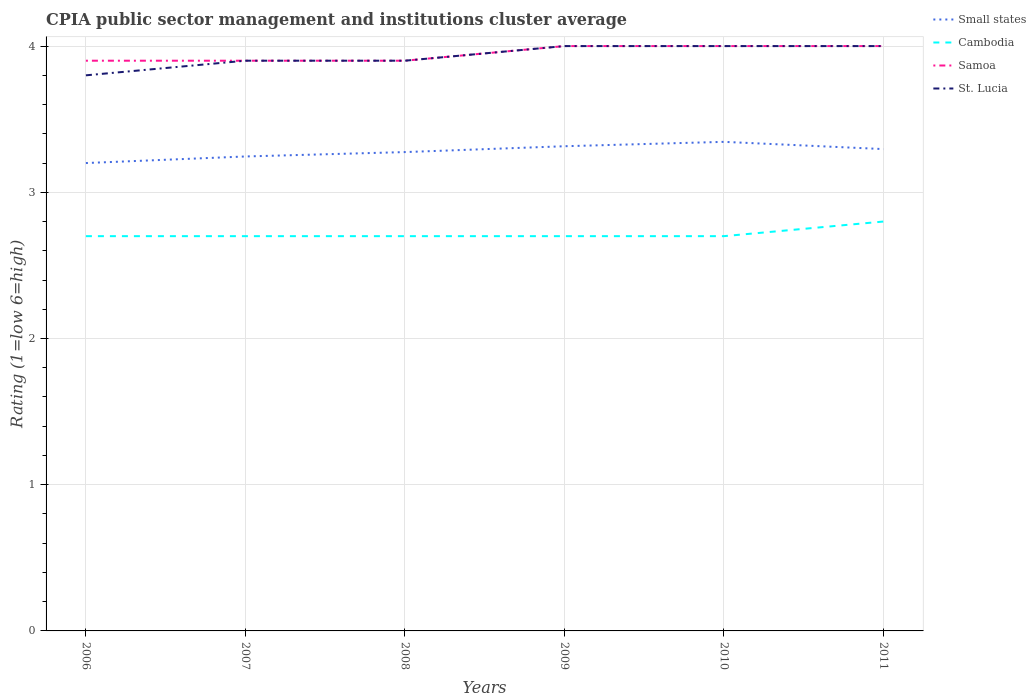How many different coloured lines are there?
Keep it short and to the point. 4. Does the line corresponding to Samoa intersect with the line corresponding to Cambodia?
Provide a succinct answer. No. Is the number of lines equal to the number of legend labels?
Provide a succinct answer. Yes. In which year was the CPIA rating in Cambodia maximum?
Your response must be concise. 2006. What is the total CPIA rating in Cambodia in the graph?
Offer a very short reply. -0.1. What is the difference between the highest and the second highest CPIA rating in Cambodia?
Keep it short and to the point. 0.1. Is the CPIA rating in St. Lucia strictly greater than the CPIA rating in Small states over the years?
Ensure brevity in your answer.  No. How many lines are there?
Provide a succinct answer. 4. How many years are there in the graph?
Make the answer very short. 6. What is the difference between two consecutive major ticks on the Y-axis?
Give a very brief answer. 1. Does the graph contain any zero values?
Your answer should be very brief. No. Does the graph contain grids?
Give a very brief answer. Yes. How are the legend labels stacked?
Offer a terse response. Vertical. What is the title of the graph?
Make the answer very short. CPIA public sector management and institutions cluster average. What is the label or title of the Y-axis?
Your answer should be very brief. Rating (1=low 6=high). What is the Rating (1=low 6=high) of Small states in 2006?
Give a very brief answer. 3.2. What is the Rating (1=low 6=high) in Cambodia in 2006?
Make the answer very short. 2.7. What is the Rating (1=low 6=high) in Samoa in 2006?
Your answer should be very brief. 3.9. What is the Rating (1=low 6=high) of St. Lucia in 2006?
Your answer should be compact. 3.8. What is the Rating (1=low 6=high) of Small states in 2007?
Your response must be concise. 3.25. What is the Rating (1=low 6=high) in Cambodia in 2007?
Your answer should be compact. 2.7. What is the Rating (1=low 6=high) in Samoa in 2007?
Give a very brief answer. 3.9. What is the Rating (1=low 6=high) in Small states in 2008?
Make the answer very short. 3.27. What is the Rating (1=low 6=high) in Cambodia in 2008?
Keep it short and to the point. 2.7. What is the Rating (1=low 6=high) in Samoa in 2008?
Your answer should be compact. 3.9. What is the Rating (1=low 6=high) in Small states in 2009?
Offer a very short reply. 3.31. What is the Rating (1=low 6=high) of St. Lucia in 2009?
Keep it short and to the point. 4. What is the Rating (1=low 6=high) of Small states in 2010?
Give a very brief answer. 3.35. What is the Rating (1=low 6=high) in Samoa in 2010?
Your answer should be very brief. 4. What is the Rating (1=low 6=high) in St. Lucia in 2010?
Give a very brief answer. 4. What is the Rating (1=low 6=high) of Small states in 2011?
Offer a terse response. 3.3. What is the Rating (1=low 6=high) of Cambodia in 2011?
Your answer should be very brief. 2.8. Across all years, what is the maximum Rating (1=low 6=high) of Small states?
Your answer should be very brief. 3.35. Across all years, what is the maximum Rating (1=low 6=high) in Cambodia?
Your answer should be very brief. 2.8. Across all years, what is the maximum Rating (1=low 6=high) in St. Lucia?
Your answer should be compact. 4. Across all years, what is the minimum Rating (1=low 6=high) of Small states?
Your response must be concise. 3.2. What is the total Rating (1=low 6=high) of Small states in the graph?
Your answer should be very brief. 19.68. What is the total Rating (1=low 6=high) of Cambodia in the graph?
Provide a short and direct response. 16.3. What is the total Rating (1=low 6=high) in Samoa in the graph?
Offer a terse response. 23.7. What is the total Rating (1=low 6=high) in St. Lucia in the graph?
Provide a succinct answer. 23.6. What is the difference between the Rating (1=low 6=high) of Small states in 2006 and that in 2007?
Offer a very short reply. -0.04. What is the difference between the Rating (1=low 6=high) of Cambodia in 2006 and that in 2007?
Give a very brief answer. 0. What is the difference between the Rating (1=low 6=high) in Samoa in 2006 and that in 2007?
Your answer should be very brief. 0. What is the difference between the Rating (1=low 6=high) in St. Lucia in 2006 and that in 2007?
Give a very brief answer. -0.1. What is the difference between the Rating (1=low 6=high) in Small states in 2006 and that in 2008?
Offer a terse response. -0.07. What is the difference between the Rating (1=low 6=high) in Cambodia in 2006 and that in 2008?
Your response must be concise. 0. What is the difference between the Rating (1=low 6=high) of St. Lucia in 2006 and that in 2008?
Provide a short and direct response. -0.1. What is the difference between the Rating (1=low 6=high) in Small states in 2006 and that in 2009?
Make the answer very short. -0.12. What is the difference between the Rating (1=low 6=high) of Cambodia in 2006 and that in 2009?
Your response must be concise. 0. What is the difference between the Rating (1=low 6=high) in Samoa in 2006 and that in 2009?
Offer a very short reply. -0.1. What is the difference between the Rating (1=low 6=high) in St. Lucia in 2006 and that in 2009?
Offer a very short reply. -0.2. What is the difference between the Rating (1=low 6=high) in Small states in 2006 and that in 2010?
Your response must be concise. -0.14. What is the difference between the Rating (1=low 6=high) in Cambodia in 2006 and that in 2010?
Your answer should be compact. 0. What is the difference between the Rating (1=low 6=high) of Small states in 2006 and that in 2011?
Give a very brief answer. -0.1. What is the difference between the Rating (1=low 6=high) in Cambodia in 2006 and that in 2011?
Give a very brief answer. -0.1. What is the difference between the Rating (1=low 6=high) in Samoa in 2006 and that in 2011?
Make the answer very short. -0.1. What is the difference between the Rating (1=low 6=high) of Small states in 2007 and that in 2008?
Your response must be concise. -0.03. What is the difference between the Rating (1=low 6=high) of Cambodia in 2007 and that in 2008?
Keep it short and to the point. 0. What is the difference between the Rating (1=low 6=high) in Samoa in 2007 and that in 2008?
Offer a very short reply. 0. What is the difference between the Rating (1=low 6=high) of St. Lucia in 2007 and that in 2008?
Provide a succinct answer. 0. What is the difference between the Rating (1=low 6=high) of Small states in 2007 and that in 2009?
Make the answer very short. -0.07. What is the difference between the Rating (1=low 6=high) of Cambodia in 2007 and that in 2009?
Offer a very short reply. 0. What is the difference between the Rating (1=low 6=high) of Samoa in 2007 and that in 2009?
Keep it short and to the point. -0.1. What is the difference between the Rating (1=low 6=high) in Small states in 2007 and that in 2010?
Provide a succinct answer. -0.1. What is the difference between the Rating (1=low 6=high) in St. Lucia in 2007 and that in 2010?
Provide a succinct answer. -0.1. What is the difference between the Rating (1=low 6=high) of Small states in 2007 and that in 2011?
Your response must be concise. -0.05. What is the difference between the Rating (1=low 6=high) of Samoa in 2007 and that in 2011?
Give a very brief answer. -0.1. What is the difference between the Rating (1=low 6=high) in Small states in 2008 and that in 2009?
Your answer should be very brief. -0.04. What is the difference between the Rating (1=low 6=high) in St. Lucia in 2008 and that in 2009?
Make the answer very short. -0.1. What is the difference between the Rating (1=low 6=high) in Small states in 2008 and that in 2010?
Keep it short and to the point. -0.07. What is the difference between the Rating (1=low 6=high) in Cambodia in 2008 and that in 2010?
Offer a terse response. 0. What is the difference between the Rating (1=low 6=high) in Samoa in 2008 and that in 2010?
Your answer should be very brief. -0.1. What is the difference between the Rating (1=low 6=high) in Small states in 2008 and that in 2011?
Provide a succinct answer. -0.02. What is the difference between the Rating (1=low 6=high) in Small states in 2009 and that in 2010?
Give a very brief answer. -0.03. What is the difference between the Rating (1=low 6=high) of Cambodia in 2009 and that in 2010?
Your answer should be very brief. 0. What is the difference between the Rating (1=low 6=high) in St. Lucia in 2009 and that in 2010?
Offer a very short reply. 0. What is the difference between the Rating (1=low 6=high) of Small states in 2009 and that in 2011?
Your response must be concise. 0.02. What is the difference between the Rating (1=low 6=high) in St. Lucia in 2009 and that in 2011?
Your answer should be very brief. 0. What is the difference between the Rating (1=low 6=high) of Small states in 2010 and that in 2011?
Make the answer very short. 0.05. What is the difference between the Rating (1=low 6=high) of Cambodia in 2010 and that in 2011?
Your answer should be very brief. -0.1. What is the difference between the Rating (1=low 6=high) of Samoa in 2010 and that in 2011?
Your answer should be compact. 0. What is the difference between the Rating (1=low 6=high) of Small states in 2006 and the Rating (1=low 6=high) of St. Lucia in 2007?
Offer a very short reply. -0.7. What is the difference between the Rating (1=low 6=high) in Cambodia in 2006 and the Rating (1=low 6=high) in St. Lucia in 2007?
Make the answer very short. -1.2. What is the difference between the Rating (1=low 6=high) of Samoa in 2006 and the Rating (1=low 6=high) of St. Lucia in 2007?
Your answer should be compact. 0. What is the difference between the Rating (1=low 6=high) in Small states in 2006 and the Rating (1=low 6=high) in Cambodia in 2008?
Offer a very short reply. 0.5. What is the difference between the Rating (1=low 6=high) of Cambodia in 2006 and the Rating (1=low 6=high) of St. Lucia in 2008?
Offer a terse response. -1.2. What is the difference between the Rating (1=low 6=high) of Small states in 2006 and the Rating (1=low 6=high) of Samoa in 2009?
Offer a very short reply. -0.8. What is the difference between the Rating (1=low 6=high) in Small states in 2006 and the Rating (1=low 6=high) in St. Lucia in 2009?
Your answer should be very brief. -0.8. What is the difference between the Rating (1=low 6=high) of Cambodia in 2006 and the Rating (1=low 6=high) of Samoa in 2009?
Your answer should be very brief. -1.3. What is the difference between the Rating (1=low 6=high) in Small states in 2006 and the Rating (1=low 6=high) in Samoa in 2010?
Your answer should be very brief. -0.8. What is the difference between the Rating (1=low 6=high) of Cambodia in 2006 and the Rating (1=low 6=high) of Samoa in 2010?
Make the answer very short. -1.3. What is the difference between the Rating (1=low 6=high) in Small states in 2006 and the Rating (1=low 6=high) in Samoa in 2011?
Offer a very short reply. -0.8. What is the difference between the Rating (1=low 6=high) of Small states in 2006 and the Rating (1=low 6=high) of St. Lucia in 2011?
Ensure brevity in your answer.  -0.8. What is the difference between the Rating (1=low 6=high) of Samoa in 2006 and the Rating (1=low 6=high) of St. Lucia in 2011?
Give a very brief answer. -0.1. What is the difference between the Rating (1=low 6=high) of Small states in 2007 and the Rating (1=low 6=high) of Cambodia in 2008?
Make the answer very short. 0.55. What is the difference between the Rating (1=low 6=high) in Small states in 2007 and the Rating (1=low 6=high) in Samoa in 2008?
Ensure brevity in your answer.  -0.66. What is the difference between the Rating (1=low 6=high) of Small states in 2007 and the Rating (1=low 6=high) of St. Lucia in 2008?
Your response must be concise. -0.66. What is the difference between the Rating (1=low 6=high) of Cambodia in 2007 and the Rating (1=low 6=high) of Samoa in 2008?
Ensure brevity in your answer.  -1.2. What is the difference between the Rating (1=low 6=high) of Small states in 2007 and the Rating (1=low 6=high) of Cambodia in 2009?
Offer a terse response. 0.55. What is the difference between the Rating (1=low 6=high) in Small states in 2007 and the Rating (1=low 6=high) in Samoa in 2009?
Make the answer very short. -0.76. What is the difference between the Rating (1=low 6=high) in Small states in 2007 and the Rating (1=low 6=high) in St. Lucia in 2009?
Keep it short and to the point. -0.76. What is the difference between the Rating (1=low 6=high) of Cambodia in 2007 and the Rating (1=low 6=high) of St. Lucia in 2009?
Your response must be concise. -1.3. What is the difference between the Rating (1=low 6=high) in Small states in 2007 and the Rating (1=low 6=high) in Cambodia in 2010?
Your answer should be compact. 0.55. What is the difference between the Rating (1=low 6=high) of Small states in 2007 and the Rating (1=low 6=high) of Samoa in 2010?
Your answer should be compact. -0.76. What is the difference between the Rating (1=low 6=high) of Small states in 2007 and the Rating (1=low 6=high) of St. Lucia in 2010?
Your answer should be very brief. -0.76. What is the difference between the Rating (1=low 6=high) in Samoa in 2007 and the Rating (1=low 6=high) in St. Lucia in 2010?
Make the answer very short. -0.1. What is the difference between the Rating (1=low 6=high) of Small states in 2007 and the Rating (1=low 6=high) of Cambodia in 2011?
Your answer should be very brief. 0.45. What is the difference between the Rating (1=low 6=high) of Small states in 2007 and the Rating (1=low 6=high) of Samoa in 2011?
Give a very brief answer. -0.76. What is the difference between the Rating (1=low 6=high) in Small states in 2007 and the Rating (1=low 6=high) in St. Lucia in 2011?
Make the answer very short. -0.76. What is the difference between the Rating (1=low 6=high) of Small states in 2008 and the Rating (1=low 6=high) of Cambodia in 2009?
Keep it short and to the point. 0.57. What is the difference between the Rating (1=low 6=high) in Small states in 2008 and the Rating (1=low 6=high) in Samoa in 2009?
Offer a terse response. -0.72. What is the difference between the Rating (1=low 6=high) of Small states in 2008 and the Rating (1=low 6=high) of St. Lucia in 2009?
Ensure brevity in your answer.  -0.72. What is the difference between the Rating (1=low 6=high) in Cambodia in 2008 and the Rating (1=low 6=high) in Samoa in 2009?
Make the answer very short. -1.3. What is the difference between the Rating (1=low 6=high) in Small states in 2008 and the Rating (1=low 6=high) in Cambodia in 2010?
Offer a very short reply. 0.57. What is the difference between the Rating (1=low 6=high) of Small states in 2008 and the Rating (1=low 6=high) of Samoa in 2010?
Provide a succinct answer. -0.72. What is the difference between the Rating (1=low 6=high) in Small states in 2008 and the Rating (1=low 6=high) in St. Lucia in 2010?
Provide a succinct answer. -0.72. What is the difference between the Rating (1=low 6=high) in Cambodia in 2008 and the Rating (1=low 6=high) in Samoa in 2010?
Keep it short and to the point. -1.3. What is the difference between the Rating (1=low 6=high) in Cambodia in 2008 and the Rating (1=low 6=high) in St. Lucia in 2010?
Ensure brevity in your answer.  -1.3. What is the difference between the Rating (1=low 6=high) in Samoa in 2008 and the Rating (1=low 6=high) in St. Lucia in 2010?
Offer a very short reply. -0.1. What is the difference between the Rating (1=low 6=high) of Small states in 2008 and the Rating (1=low 6=high) of Cambodia in 2011?
Your answer should be compact. 0.47. What is the difference between the Rating (1=low 6=high) of Small states in 2008 and the Rating (1=low 6=high) of Samoa in 2011?
Provide a succinct answer. -0.72. What is the difference between the Rating (1=low 6=high) of Small states in 2008 and the Rating (1=low 6=high) of St. Lucia in 2011?
Keep it short and to the point. -0.72. What is the difference between the Rating (1=low 6=high) in Small states in 2009 and the Rating (1=low 6=high) in Cambodia in 2010?
Provide a succinct answer. 0.61. What is the difference between the Rating (1=low 6=high) of Small states in 2009 and the Rating (1=low 6=high) of Samoa in 2010?
Provide a short and direct response. -0.69. What is the difference between the Rating (1=low 6=high) in Small states in 2009 and the Rating (1=low 6=high) in St. Lucia in 2010?
Keep it short and to the point. -0.69. What is the difference between the Rating (1=low 6=high) in Cambodia in 2009 and the Rating (1=low 6=high) in Samoa in 2010?
Keep it short and to the point. -1.3. What is the difference between the Rating (1=low 6=high) of Cambodia in 2009 and the Rating (1=low 6=high) of St. Lucia in 2010?
Your answer should be very brief. -1.3. What is the difference between the Rating (1=low 6=high) of Small states in 2009 and the Rating (1=low 6=high) of Cambodia in 2011?
Keep it short and to the point. 0.52. What is the difference between the Rating (1=low 6=high) in Small states in 2009 and the Rating (1=low 6=high) in Samoa in 2011?
Keep it short and to the point. -0.69. What is the difference between the Rating (1=low 6=high) of Small states in 2009 and the Rating (1=low 6=high) of St. Lucia in 2011?
Offer a terse response. -0.69. What is the difference between the Rating (1=low 6=high) in Cambodia in 2009 and the Rating (1=low 6=high) in Samoa in 2011?
Ensure brevity in your answer.  -1.3. What is the difference between the Rating (1=low 6=high) in Small states in 2010 and the Rating (1=low 6=high) in Cambodia in 2011?
Ensure brevity in your answer.  0.55. What is the difference between the Rating (1=low 6=high) in Small states in 2010 and the Rating (1=low 6=high) in Samoa in 2011?
Give a very brief answer. -0.66. What is the difference between the Rating (1=low 6=high) in Small states in 2010 and the Rating (1=low 6=high) in St. Lucia in 2011?
Give a very brief answer. -0.66. What is the difference between the Rating (1=low 6=high) of Cambodia in 2010 and the Rating (1=low 6=high) of St. Lucia in 2011?
Give a very brief answer. -1.3. What is the average Rating (1=low 6=high) of Small states per year?
Provide a succinct answer. 3.28. What is the average Rating (1=low 6=high) of Cambodia per year?
Make the answer very short. 2.72. What is the average Rating (1=low 6=high) in Samoa per year?
Your answer should be very brief. 3.95. What is the average Rating (1=low 6=high) of St. Lucia per year?
Provide a short and direct response. 3.93. In the year 2006, what is the difference between the Rating (1=low 6=high) of Small states and Rating (1=low 6=high) of St. Lucia?
Offer a very short reply. -0.6. In the year 2006, what is the difference between the Rating (1=low 6=high) of Samoa and Rating (1=low 6=high) of St. Lucia?
Your answer should be compact. 0.1. In the year 2007, what is the difference between the Rating (1=low 6=high) in Small states and Rating (1=low 6=high) in Cambodia?
Make the answer very short. 0.55. In the year 2007, what is the difference between the Rating (1=low 6=high) of Small states and Rating (1=low 6=high) of Samoa?
Provide a short and direct response. -0.66. In the year 2007, what is the difference between the Rating (1=low 6=high) of Small states and Rating (1=low 6=high) of St. Lucia?
Provide a short and direct response. -0.66. In the year 2007, what is the difference between the Rating (1=low 6=high) in Cambodia and Rating (1=low 6=high) in Samoa?
Your answer should be compact. -1.2. In the year 2007, what is the difference between the Rating (1=low 6=high) in Cambodia and Rating (1=low 6=high) in St. Lucia?
Your answer should be compact. -1.2. In the year 2008, what is the difference between the Rating (1=low 6=high) in Small states and Rating (1=low 6=high) in Cambodia?
Provide a short and direct response. 0.57. In the year 2008, what is the difference between the Rating (1=low 6=high) in Small states and Rating (1=low 6=high) in Samoa?
Your response must be concise. -0.62. In the year 2008, what is the difference between the Rating (1=low 6=high) in Small states and Rating (1=low 6=high) in St. Lucia?
Offer a very short reply. -0.62. In the year 2008, what is the difference between the Rating (1=low 6=high) in Cambodia and Rating (1=low 6=high) in St. Lucia?
Offer a terse response. -1.2. In the year 2009, what is the difference between the Rating (1=low 6=high) of Small states and Rating (1=low 6=high) of Cambodia?
Make the answer very short. 0.61. In the year 2009, what is the difference between the Rating (1=low 6=high) in Small states and Rating (1=low 6=high) in Samoa?
Give a very brief answer. -0.69. In the year 2009, what is the difference between the Rating (1=low 6=high) of Small states and Rating (1=low 6=high) of St. Lucia?
Provide a succinct answer. -0.69. In the year 2009, what is the difference between the Rating (1=low 6=high) in Cambodia and Rating (1=low 6=high) in Samoa?
Provide a succinct answer. -1.3. In the year 2009, what is the difference between the Rating (1=low 6=high) in Samoa and Rating (1=low 6=high) in St. Lucia?
Provide a short and direct response. 0. In the year 2010, what is the difference between the Rating (1=low 6=high) in Small states and Rating (1=low 6=high) in Cambodia?
Provide a short and direct response. 0.65. In the year 2010, what is the difference between the Rating (1=low 6=high) of Small states and Rating (1=low 6=high) of Samoa?
Give a very brief answer. -0.66. In the year 2010, what is the difference between the Rating (1=low 6=high) of Small states and Rating (1=low 6=high) of St. Lucia?
Offer a terse response. -0.66. In the year 2010, what is the difference between the Rating (1=low 6=high) of Cambodia and Rating (1=low 6=high) of St. Lucia?
Keep it short and to the point. -1.3. In the year 2010, what is the difference between the Rating (1=low 6=high) of Samoa and Rating (1=low 6=high) of St. Lucia?
Make the answer very short. 0. In the year 2011, what is the difference between the Rating (1=low 6=high) of Small states and Rating (1=low 6=high) of Cambodia?
Ensure brevity in your answer.  0.5. In the year 2011, what is the difference between the Rating (1=low 6=high) in Small states and Rating (1=low 6=high) in Samoa?
Offer a terse response. -0.7. In the year 2011, what is the difference between the Rating (1=low 6=high) in Small states and Rating (1=low 6=high) in St. Lucia?
Your answer should be very brief. -0.7. In the year 2011, what is the difference between the Rating (1=low 6=high) in Cambodia and Rating (1=low 6=high) in Samoa?
Keep it short and to the point. -1.2. In the year 2011, what is the difference between the Rating (1=low 6=high) of Samoa and Rating (1=low 6=high) of St. Lucia?
Provide a short and direct response. 0. What is the ratio of the Rating (1=low 6=high) in Small states in 2006 to that in 2007?
Give a very brief answer. 0.99. What is the ratio of the Rating (1=low 6=high) in Cambodia in 2006 to that in 2007?
Your answer should be compact. 1. What is the ratio of the Rating (1=low 6=high) in St. Lucia in 2006 to that in 2007?
Offer a very short reply. 0.97. What is the ratio of the Rating (1=low 6=high) in Small states in 2006 to that in 2008?
Ensure brevity in your answer.  0.98. What is the ratio of the Rating (1=low 6=high) in Cambodia in 2006 to that in 2008?
Provide a succinct answer. 1. What is the ratio of the Rating (1=low 6=high) in St. Lucia in 2006 to that in 2008?
Your response must be concise. 0.97. What is the ratio of the Rating (1=low 6=high) in Small states in 2006 to that in 2009?
Offer a very short reply. 0.97. What is the ratio of the Rating (1=low 6=high) of Cambodia in 2006 to that in 2009?
Your response must be concise. 1. What is the ratio of the Rating (1=low 6=high) in St. Lucia in 2006 to that in 2009?
Your answer should be compact. 0.95. What is the ratio of the Rating (1=low 6=high) in Small states in 2006 to that in 2010?
Your answer should be compact. 0.96. What is the ratio of the Rating (1=low 6=high) of Small states in 2006 to that in 2011?
Provide a succinct answer. 0.97. What is the ratio of the Rating (1=low 6=high) of Cambodia in 2006 to that in 2011?
Offer a terse response. 0.96. What is the ratio of the Rating (1=low 6=high) of Samoa in 2006 to that in 2011?
Ensure brevity in your answer.  0.97. What is the ratio of the Rating (1=low 6=high) of Cambodia in 2007 to that in 2008?
Your answer should be very brief. 1. What is the ratio of the Rating (1=low 6=high) in St. Lucia in 2007 to that in 2008?
Keep it short and to the point. 1. What is the ratio of the Rating (1=low 6=high) of Small states in 2007 to that in 2009?
Provide a short and direct response. 0.98. What is the ratio of the Rating (1=low 6=high) in St. Lucia in 2007 to that in 2009?
Give a very brief answer. 0.97. What is the ratio of the Rating (1=low 6=high) of Small states in 2007 to that in 2010?
Offer a terse response. 0.97. What is the ratio of the Rating (1=low 6=high) of Cambodia in 2007 to that in 2010?
Make the answer very short. 1. What is the ratio of the Rating (1=low 6=high) of Samoa in 2007 to that in 2010?
Ensure brevity in your answer.  0.97. What is the ratio of the Rating (1=low 6=high) of Small states in 2007 to that in 2011?
Your answer should be compact. 0.98. What is the ratio of the Rating (1=low 6=high) of Cambodia in 2007 to that in 2011?
Make the answer very short. 0.96. What is the ratio of the Rating (1=low 6=high) in Samoa in 2007 to that in 2011?
Offer a terse response. 0.97. What is the ratio of the Rating (1=low 6=high) of St. Lucia in 2007 to that in 2011?
Provide a succinct answer. 0.97. What is the ratio of the Rating (1=low 6=high) in Small states in 2008 to that in 2009?
Provide a succinct answer. 0.99. What is the ratio of the Rating (1=low 6=high) in Cambodia in 2008 to that in 2009?
Provide a succinct answer. 1. What is the ratio of the Rating (1=low 6=high) in Samoa in 2008 to that in 2009?
Ensure brevity in your answer.  0.97. What is the ratio of the Rating (1=low 6=high) of Small states in 2008 to that in 2010?
Give a very brief answer. 0.98. What is the ratio of the Rating (1=low 6=high) in St. Lucia in 2008 to that in 2010?
Make the answer very short. 0.97. What is the ratio of the Rating (1=low 6=high) in St. Lucia in 2008 to that in 2011?
Your response must be concise. 0.97. What is the ratio of the Rating (1=low 6=high) in Small states in 2009 to that in 2010?
Make the answer very short. 0.99. What is the ratio of the Rating (1=low 6=high) in Small states in 2009 to that in 2011?
Offer a very short reply. 1.01. What is the ratio of the Rating (1=low 6=high) of Small states in 2010 to that in 2011?
Offer a terse response. 1.01. What is the ratio of the Rating (1=low 6=high) of Samoa in 2010 to that in 2011?
Make the answer very short. 1. What is the difference between the highest and the second highest Rating (1=low 6=high) of Cambodia?
Provide a short and direct response. 0.1. What is the difference between the highest and the second highest Rating (1=low 6=high) of Samoa?
Your answer should be compact. 0. What is the difference between the highest and the lowest Rating (1=low 6=high) in Small states?
Give a very brief answer. 0.14. What is the difference between the highest and the lowest Rating (1=low 6=high) of St. Lucia?
Keep it short and to the point. 0.2. 